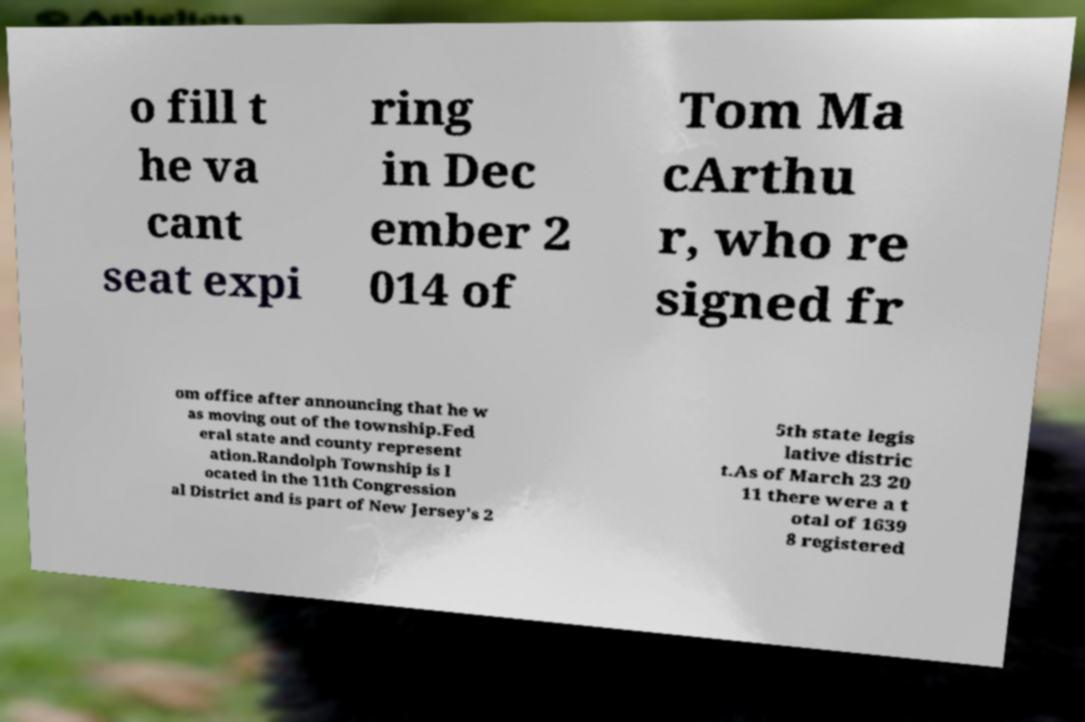Can you read and provide the text displayed in the image?This photo seems to have some interesting text. Can you extract and type it out for me? o fill t he va cant seat expi ring in Dec ember 2 014 of Tom Ma cArthu r, who re signed fr om office after announcing that he w as moving out of the township.Fed eral state and county represent ation.Randolph Township is l ocated in the 11th Congression al District and is part of New Jersey's 2 5th state legis lative distric t.As of March 23 20 11 there were a t otal of 1639 8 registered 